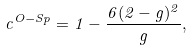<formula> <loc_0><loc_0><loc_500><loc_500>c ^ { O - S p } = 1 - \frac { 6 ( 2 - g ) ^ { 2 } } { g } ,</formula> 